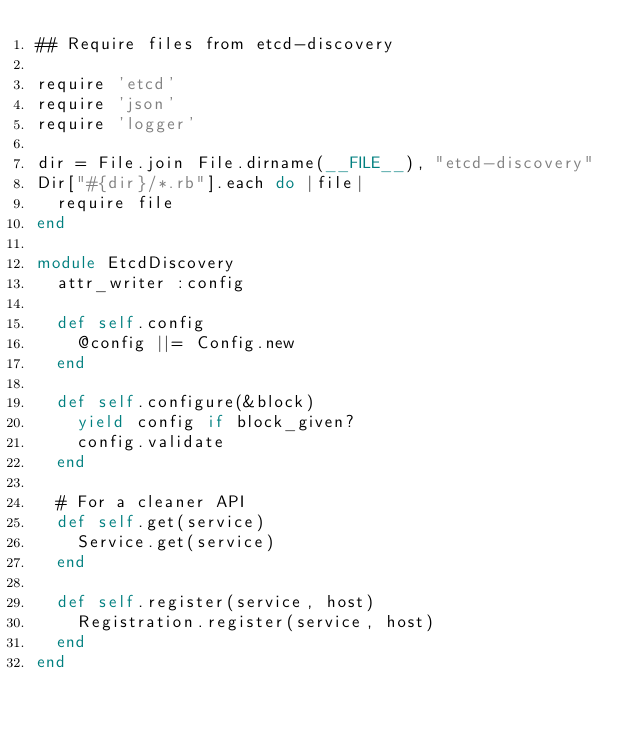<code> <loc_0><loc_0><loc_500><loc_500><_Ruby_>## Require files from etcd-discovery

require 'etcd'
require 'json'
require 'logger'

dir = File.join File.dirname(__FILE__), "etcd-discovery"
Dir["#{dir}/*.rb"].each do |file|
  require file
end

module EtcdDiscovery
  attr_writer :config

  def self.config
    @config ||= Config.new
  end

  def self.configure(&block)
    yield config if block_given?
    config.validate
  end

  # For a cleaner API
  def self.get(service)
    Service.get(service)
  end

  def self.register(service, host)
    Registration.register(service, host)
  end
end
</code> 